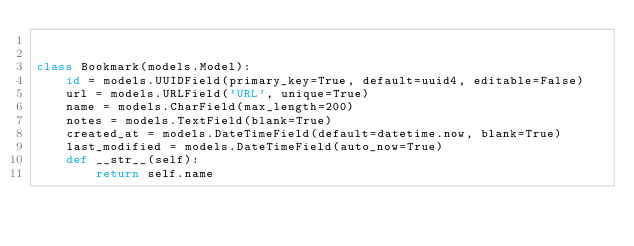Convert code to text. <code><loc_0><loc_0><loc_500><loc_500><_Python_>

class Bookmark(models.Model):
    id = models.UUIDField(primary_key=True, default=uuid4, editable=False)
    url = models.URLField('URL', unique=True)
    name = models.CharField(max_length=200)
    notes = models.TextField(blank=True)
    created_at = models.DateTimeField(default=datetime.now, blank=True)
    last_modified = models.DateTimeField(auto_now=True)
    def __str__(self):
        return self.name
</code> 